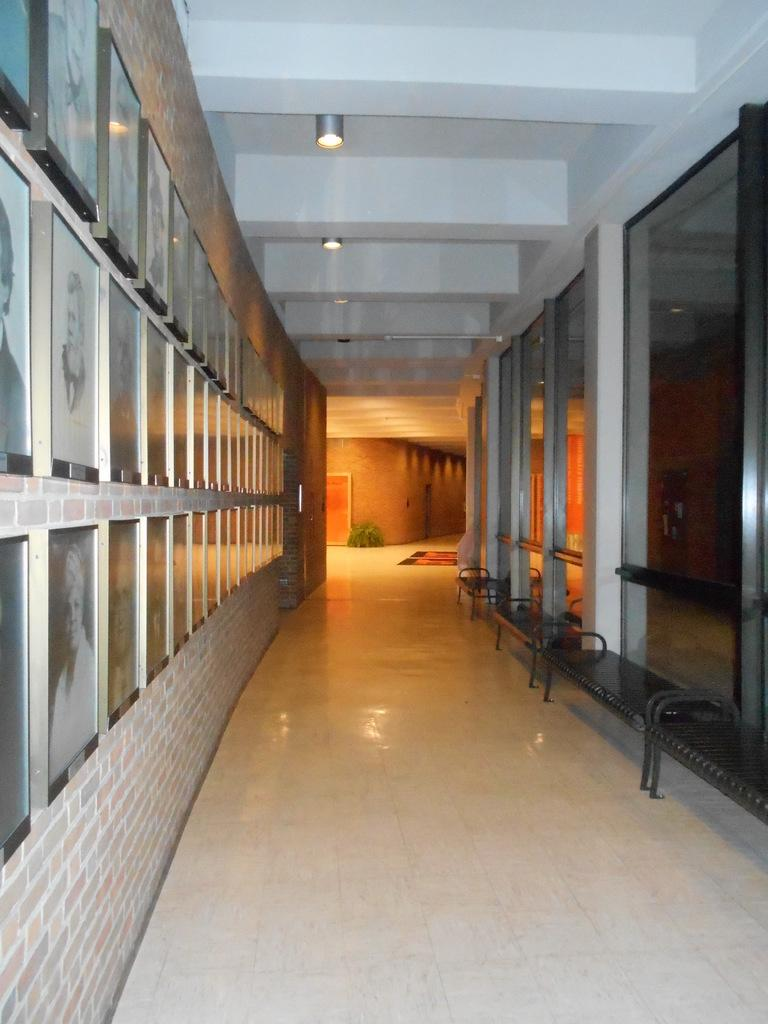What can be seen in the image that people might walk on? There is a path in the image that people might walk on. What is hanging on the wall in the image? There are frames on the wall in the image. Where are the benches located in the image? The benches are arranged inside a building in the image. How many fingers can be seen on the arm in the image? There is no arm or fingers present in the image. What type of dust can be seen on the frames in the image? There is no dust visible on the frames in the image. 